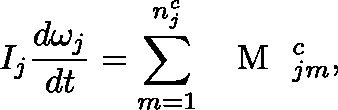Convert formula to latex. <formula><loc_0><loc_0><loc_500><loc_500>I _ { j } \frac { d \mathbf \omega _ { j } } { d t } = \sum _ { m = 1 } ^ { n _ { j } ^ { c } } \boldmath { M } _ { j m } ^ { c } ,</formula> 